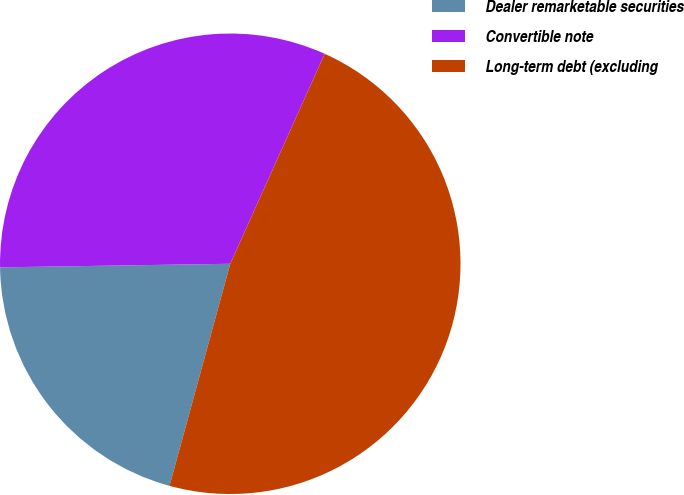Convert chart. <chart><loc_0><loc_0><loc_500><loc_500><pie_chart><fcel>Dealer remarketable securities<fcel>Convertible note<fcel>Long-term debt (excluding<nl><fcel>20.5%<fcel>31.97%<fcel>47.52%<nl></chart> 